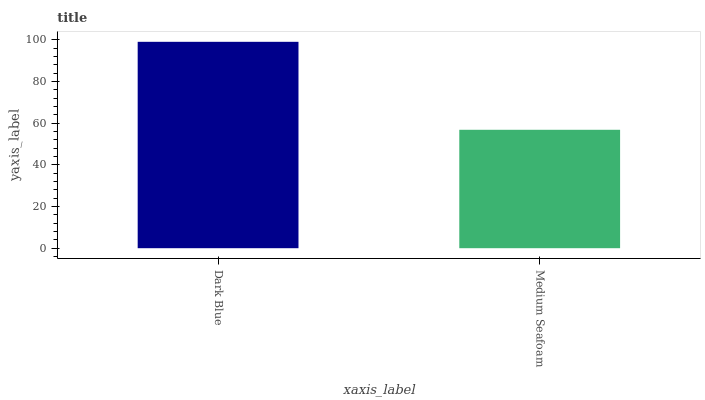Is Medium Seafoam the minimum?
Answer yes or no. Yes. Is Dark Blue the maximum?
Answer yes or no. Yes. Is Medium Seafoam the maximum?
Answer yes or no. No. Is Dark Blue greater than Medium Seafoam?
Answer yes or no. Yes. Is Medium Seafoam less than Dark Blue?
Answer yes or no. Yes. Is Medium Seafoam greater than Dark Blue?
Answer yes or no. No. Is Dark Blue less than Medium Seafoam?
Answer yes or no. No. Is Dark Blue the high median?
Answer yes or no. Yes. Is Medium Seafoam the low median?
Answer yes or no. Yes. Is Medium Seafoam the high median?
Answer yes or no. No. Is Dark Blue the low median?
Answer yes or no. No. 